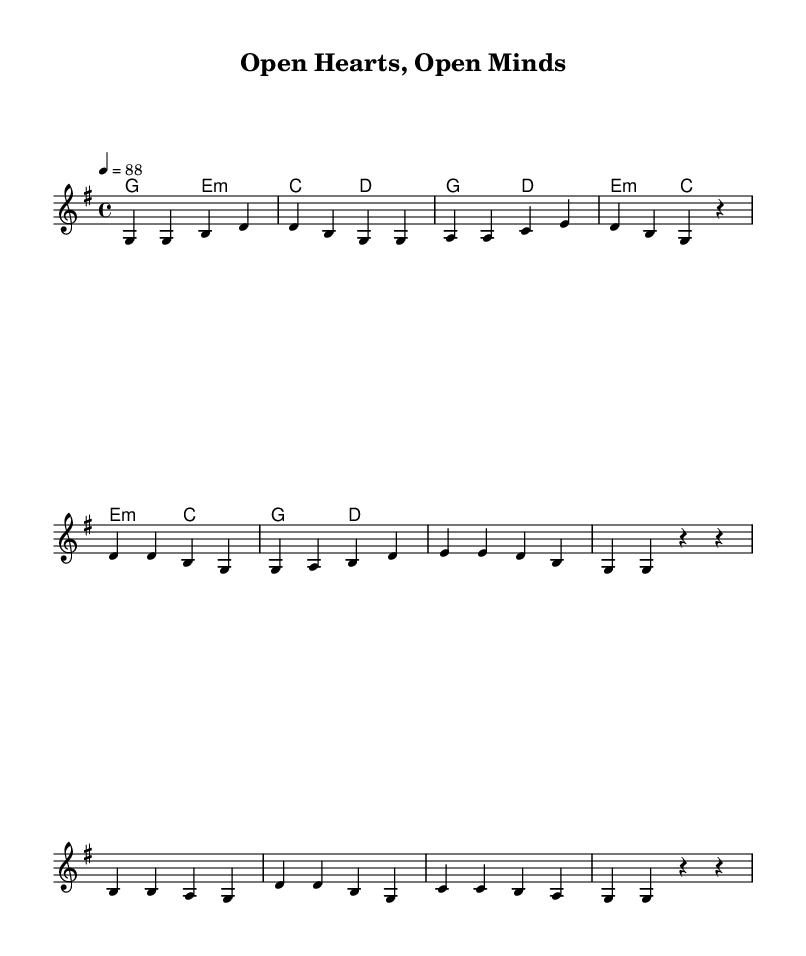What is the key signature of this music? The key signature is G major, which has one sharp (F#).
Answer: G major What is the time signature of this music? The time signature is 4/4, indicating four beats per measure.
Answer: 4/4 What is the tempo marking of this piece? The tempo marking indicates a speed of 88 beats per minute.
Answer: 88 How many lines does the melody have in the chorus? The chorus consists of four lines of melody. Each line contains specific pitches that create a musical phrase.
Answer: Four lines What is the primary theme of the song based on its lyrics? The primary theme revolves around love and acceptance, emphasizing unity and inclusivity in society.
Answer: Love and acceptance How many chords are used in the verse? The verse utilizes two distinct chords: G major and E minor.
Answer: Two What is the function of the bridge in this song? The bridge provides a contrasting section that reinforces the message of love and inclusivity before returning to the main themes of the song.
Answer: Reinforcement of message 